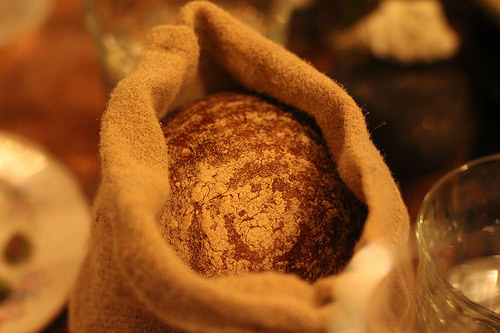<image>
Is the flour in the sack? Yes. The flour is contained within or inside the sack, showing a containment relationship. 